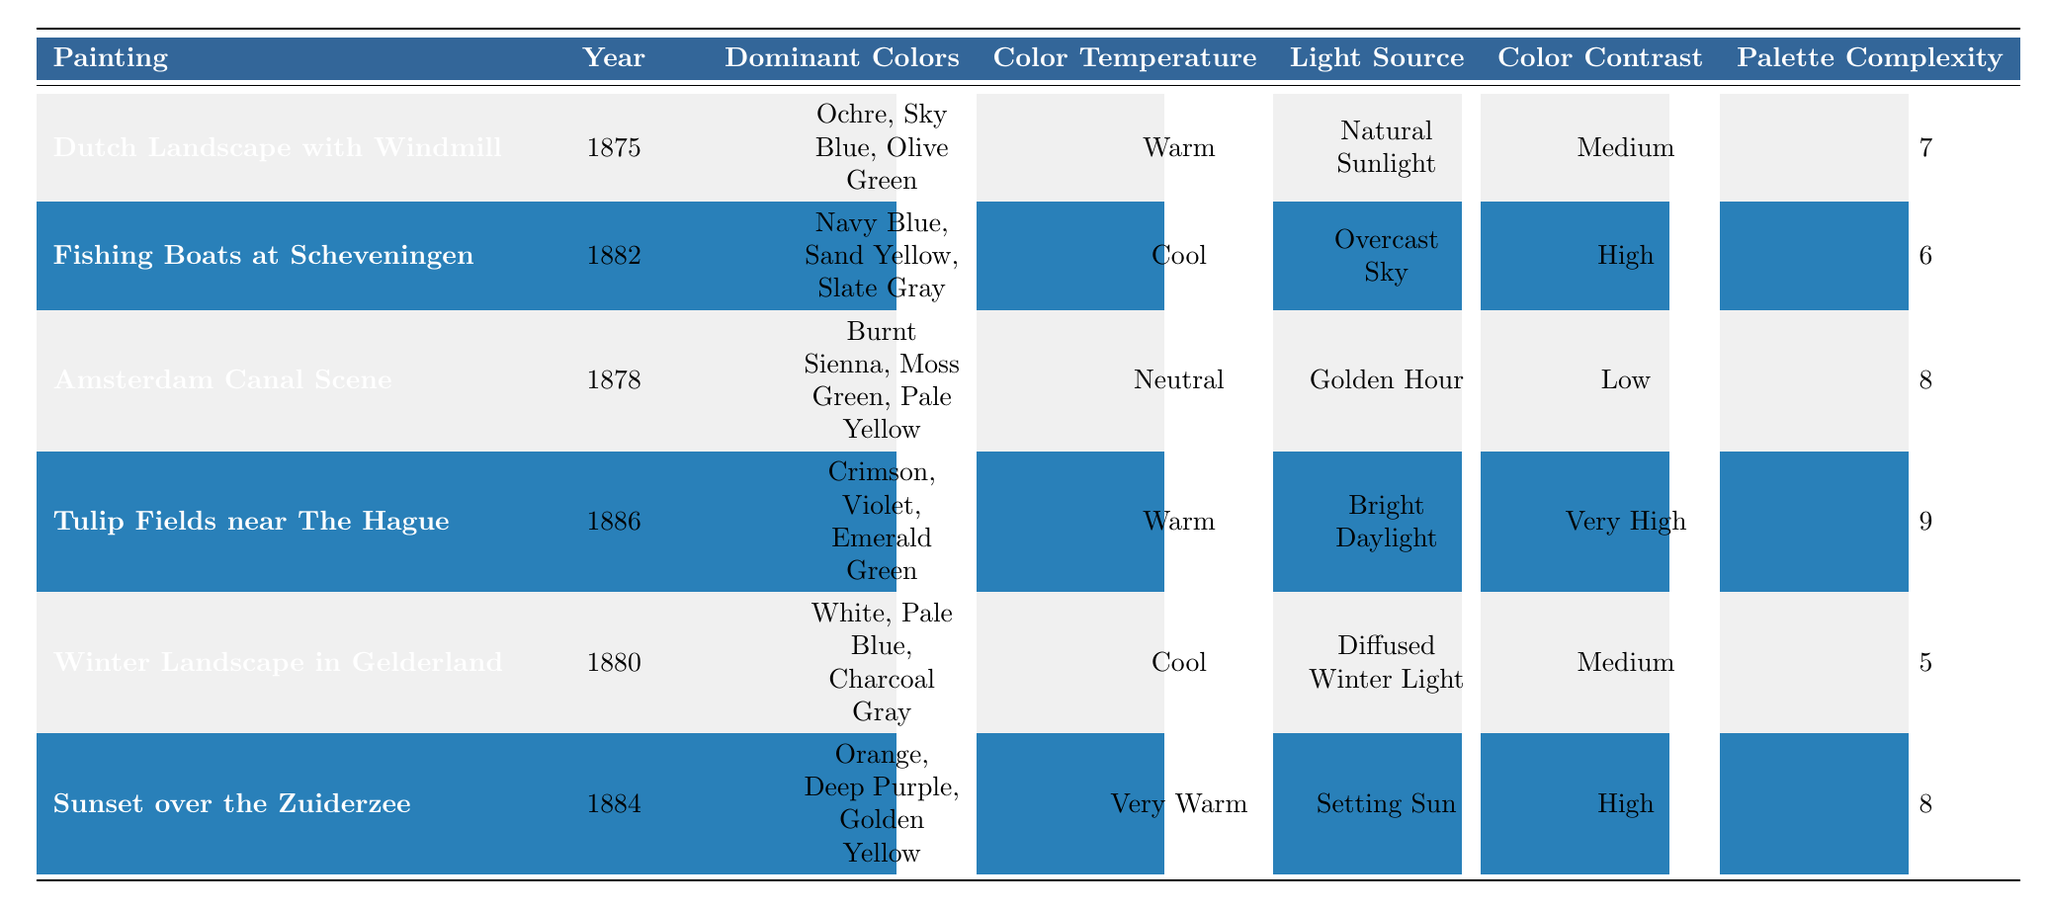What are the dominant colors of "Tulip Fields near The Hague"? Referring to the table, the row for "Tulip Fields near The Hague" lists the dominant colors as Crimson, Violet, and Emerald Green.
Answer: Crimson, Violet, Emerald Green Which painting has the highest palette complexity? Looking through the table, "Tulip Fields near The Hague" has a palette complexity of 9, which is the highest among all the paintings listed.
Answer: Tulip Fields near The Hague Is "Winter Landscape in Gelderland" painted in warm color temperature? Checking the table, "Winter Landscape in Gelderland" is listed with a cool color temperature. Therefore, the statement is false.
Answer: No How many paintings use natural sunlight as the light source? The table shows that "Dutch Landscape with Windmill" is the only painting that uses natural sunlight as the light source. Thus, there's only one painting in this category.
Answer: 1 What is the average palette complexity of the paintings? Adding the palette complexities of all paintings (7 + 6 + 8 + 9 + 5 + 8 = 43) and dividing by the number of paintings (6) gives an average of 43 / 6 = 7.17.
Answer: 7.17 Which painting has a very high color contrast and what is its year? The painting "Tulip Fields near The Hague" is noted for having very high color contrast in the table. It was painted in 1886.
Answer: Tulip Fields near The Hague, 1886 What is the difference in palette complexity between "Fishing Boats at Scheveningen" and "Sunset over the Zuiderzee"? "Fishing Boats at Scheveningen" has a palette complexity of 6, and "Sunset over the Zuiderzee" has a complexity of 8. The difference is 8 - 6 = 2.
Answer: 2 Which painting was created in the year that has the lowest color contrast? The table indicates that "Amsterdam Canal Scene" has a low color contrast, and it was created in 1878, which is the lowest among the listed paintings.
Answer: Amsterdam Canal Scene, 1878 Is it true that all paintings from 1880 and later use cool color temperatures? Checking each painting from 1880 onwards, "Winter Landscape in Gelderland" is cool, "Sunset over the Zuiderzee" is very warm, which contradicts the statement. Therefore, it is false.
Answer: No What percentage of the paintings use high color contrast? From the table, 3 out of 6 paintings have high color contrast (Fishing Boats at Scheveningen, Sunset over the Zuiderzee, and Tulip Fields near The Hague). The percentage is (3/6) * 100 = 50%.
Answer: 50% 